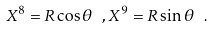Convert formula to latex. <formula><loc_0><loc_0><loc_500><loc_500>X ^ { 8 } = R \cos \theta \ , X ^ { 9 } = R \sin \theta \ .</formula> 